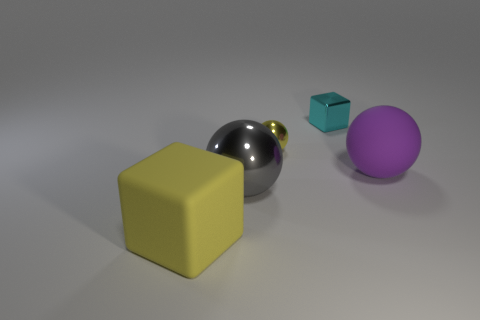What is the color of the tiny thing that is the same shape as the big metal thing?
Your response must be concise. Yellow. The thing that is the same color as the matte block is what shape?
Ensure brevity in your answer.  Sphere. Are there more small cubes than green rubber things?
Give a very brief answer. Yes. There is a metallic ball in front of the metal sphere that is behind the matte thing that is behind the big gray thing; what is its color?
Your answer should be compact. Gray. There is a tiny shiny object that is behind the small shiny ball; is it the same shape as the large purple thing?
Provide a succinct answer. No. What is the color of the metallic ball that is the same size as the yellow rubber block?
Make the answer very short. Gray. How many yellow metal things are there?
Your answer should be compact. 1. Is the big gray object that is in front of the tiny yellow metal thing made of the same material as the tiny cyan cube?
Offer a terse response. Yes. There is a thing that is both left of the tiny cyan cube and to the right of the big gray object; what is its material?
Your response must be concise. Metal. The metallic ball that is the same color as the large rubber cube is what size?
Make the answer very short. Small. 